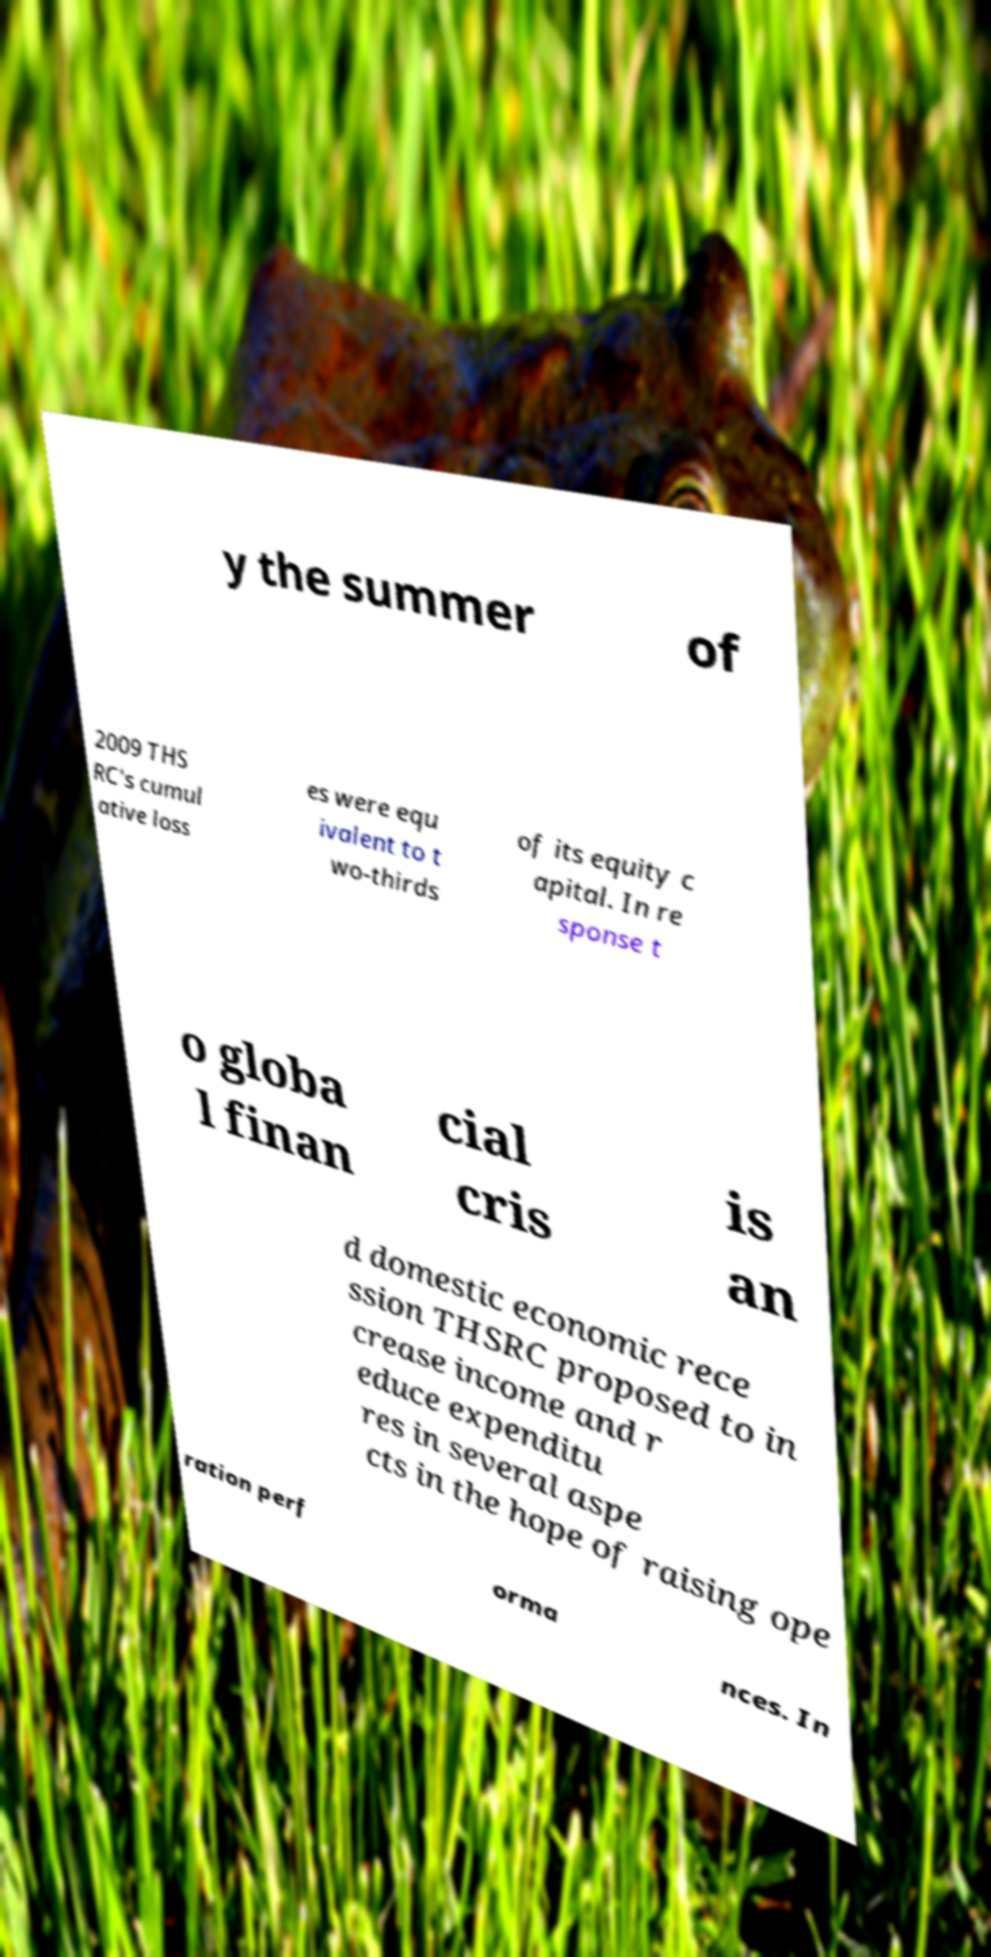What messages or text are displayed in this image? I need them in a readable, typed format. y the summer of 2009 THS RC's cumul ative loss es were equ ivalent to t wo-thirds of its equity c apital. In re sponse t o globa l finan cial cris is an d domestic economic rece ssion THSRC proposed to in crease income and r educe expenditu res in several aspe cts in the hope of raising ope ration perf orma nces. In 